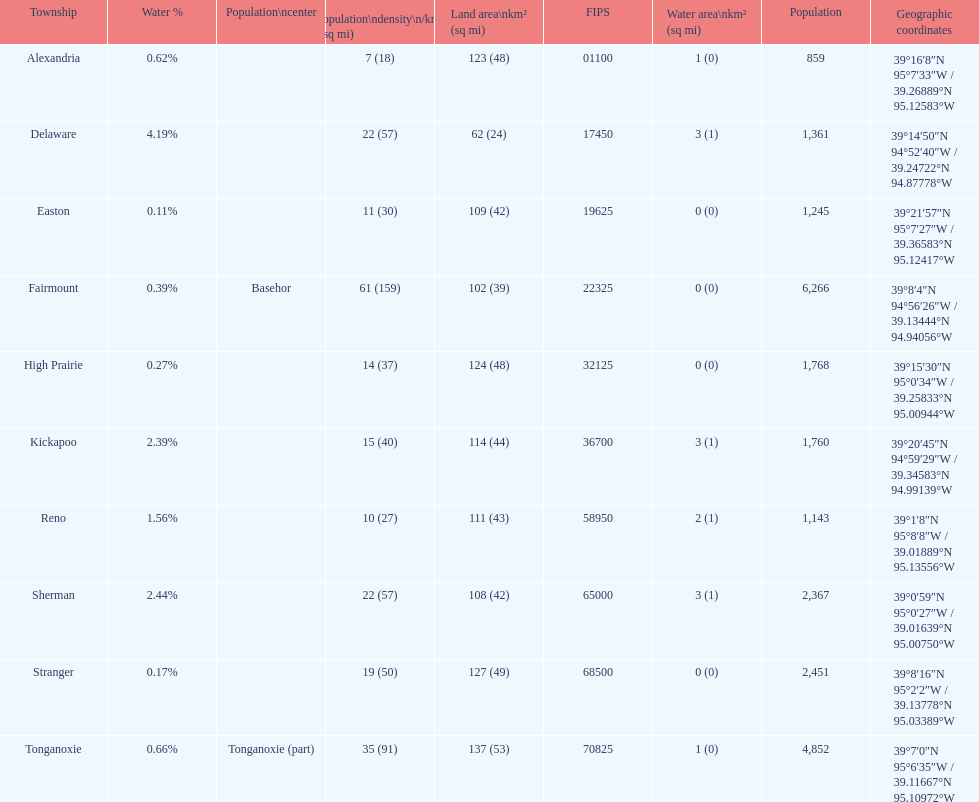Was delaware's land area above or below 45 square miles? Above. 